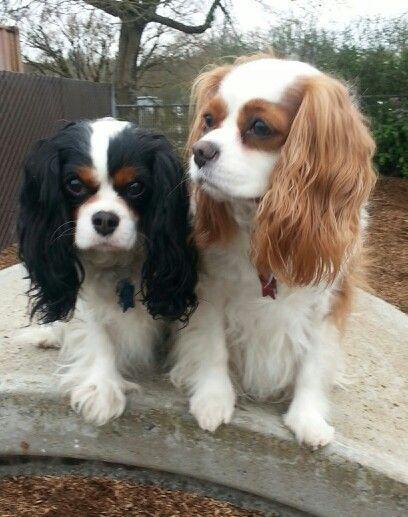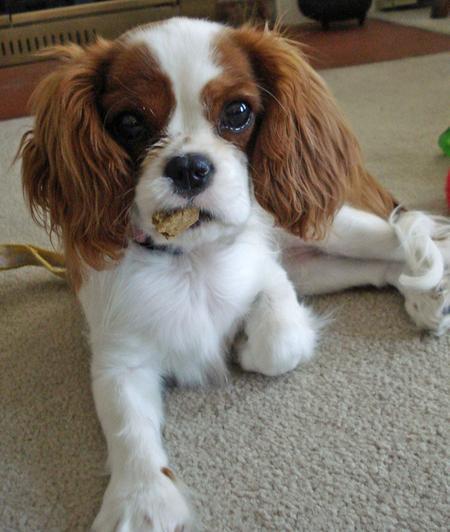The first image is the image on the left, the second image is the image on the right. Evaluate the accuracy of this statement regarding the images: "All images contain only one dog.". Is it true? Answer yes or no. No. 